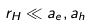<formula> <loc_0><loc_0><loc_500><loc_500>r _ { H } \ll a _ { e } , a _ { h } \,</formula> 